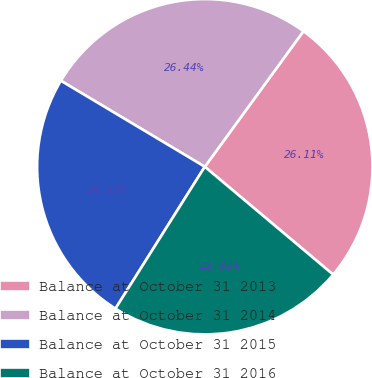Convert chart to OTSL. <chart><loc_0><loc_0><loc_500><loc_500><pie_chart><fcel>Balance at October 31 2013<fcel>Balance at October 31 2014<fcel>Balance at October 31 2015<fcel>Balance at October 31 2016<nl><fcel>26.11%<fcel>26.44%<fcel>24.63%<fcel>22.82%<nl></chart> 